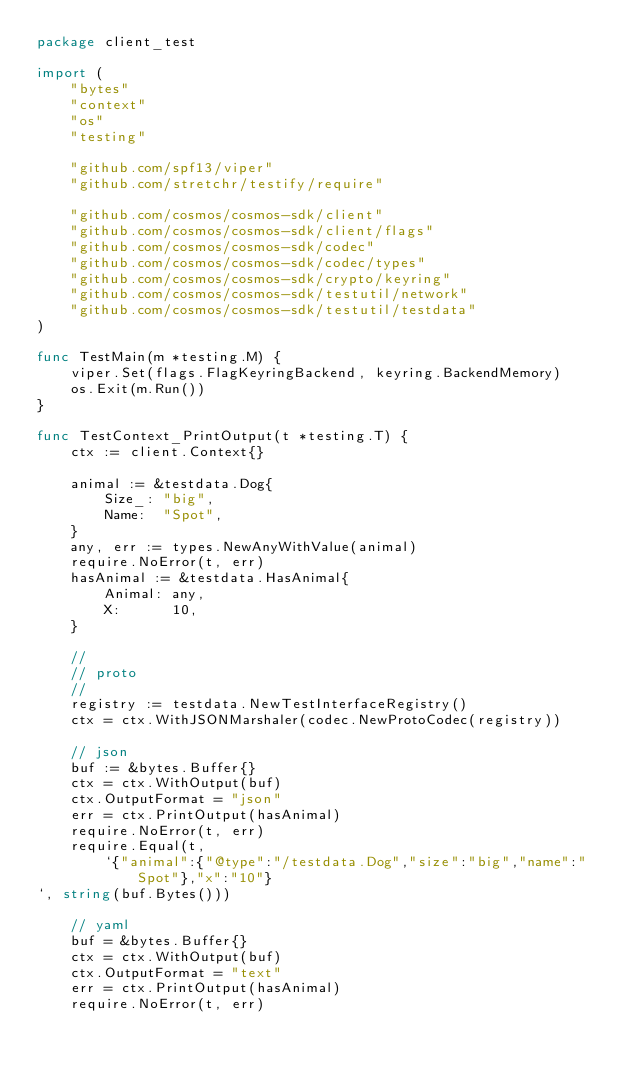Convert code to text. <code><loc_0><loc_0><loc_500><loc_500><_Go_>package client_test

import (
	"bytes"
	"context"
	"os"
	"testing"

	"github.com/spf13/viper"
	"github.com/stretchr/testify/require"

	"github.com/cosmos/cosmos-sdk/client"
	"github.com/cosmos/cosmos-sdk/client/flags"
	"github.com/cosmos/cosmos-sdk/codec"
	"github.com/cosmos/cosmos-sdk/codec/types"
	"github.com/cosmos/cosmos-sdk/crypto/keyring"
	"github.com/cosmos/cosmos-sdk/testutil/network"
	"github.com/cosmos/cosmos-sdk/testutil/testdata"
)

func TestMain(m *testing.M) {
	viper.Set(flags.FlagKeyringBackend, keyring.BackendMemory)
	os.Exit(m.Run())
}

func TestContext_PrintOutput(t *testing.T) {
	ctx := client.Context{}

	animal := &testdata.Dog{
		Size_: "big",
		Name:  "Spot",
	}
	any, err := types.NewAnyWithValue(animal)
	require.NoError(t, err)
	hasAnimal := &testdata.HasAnimal{
		Animal: any,
		X:      10,
	}

	//
	// proto
	//
	registry := testdata.NewTestInterfaceRegistry()
	ctx = ctx.WithJSONMarshaler(codec.NewProtoCodec(registry))

	// json
	buf := &bytes.Buffer{}
	ctx = ctx.WithOutput(buf)
	ctx.OutputFormat = "json"
	err = ctx.PrintOutput(hasAnimal)
	require.NoError(t, err)
	require.Equal(t,
		`{"animal":{"@type":"/testdata.Dog","size":"big","name":"Spot"},"x":"10"}
`, string(buf.Bytes()))

	// yaml
	buf = &bytes.Buffer{}
	ctx = ctx.WithOutput(buf)
	ctx.OutputFormat = "text"
	err = ctx.PrintOutput(hasAnimal)
	require.NoError(t, err)</code> 